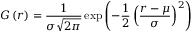<formula> <loc_0><loc_0><loc_500><loc_500>G \left ( r \right ) = \frac { 1 } { \sigma \sqrt { 2 \pi } } \exp \left ( - { \frac { 1 } { 2 } } \left ( \frac { r - \mu } { \sigma } \right ) ^ { 2 } \right )</formula> 